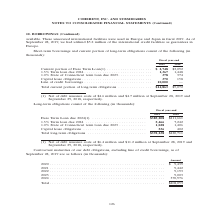According to Coherent's financial document, What does the Euro Term Loan due 2024 consist of? Net of debt issuance costs of $6.4 million and $11.2 million at September 28, 2019 and September 29, 2018, respectively.. The document states: "(1) Net of debt issuance costs of $6.4 million and $11.2 million at September 28, 2019 and September 29, 2018, respectively...." Also, What was the Total long-term obligations in 2019? According to the financial document, $392,238 (in thousands). The relevant text states: "Total long-term obligations . $392,238 $420,711..." Also, In which years was Total long-term obligations calculated? The document shows two values: 2019 and 2018. From the document: "Fiscal year-end 2019 2018 Fiscal year-end 2019 2018..." Additionally, In which year was the 1.0% State of Connecticut term loan due 2023 larger? According to the financial document, 2018. The relevant text states: "Fiscal year-end 2019 2018..." Also, can you calculate: What was the change in Capital lease obligations from 2018 to 2019? Based on the calculation: 536-402, the result is 134 (in thousands). This is based on the information: "023 . 1,028 1,406 Capital lease obligations . 536 402 ue 2023 . 1,028 1,406 Capital lease obligations . 536 402..." The key data points involved are: 402, 536. Also, can you calculate: What was the percentage change in Capital lease obligations from 2018 to 2019? To answer this question, I need to perform calculations using the financial data. The calculation is: (536-402)/402, which equals 33.33 (percentage). This is based on the information: "023 . 1,028 1,406 Capital lease obligations . 536 402 ue 2023 . 1,028 1,406 Capital lease obligations . 536 402..." The key data points involved are: 402, 536. 